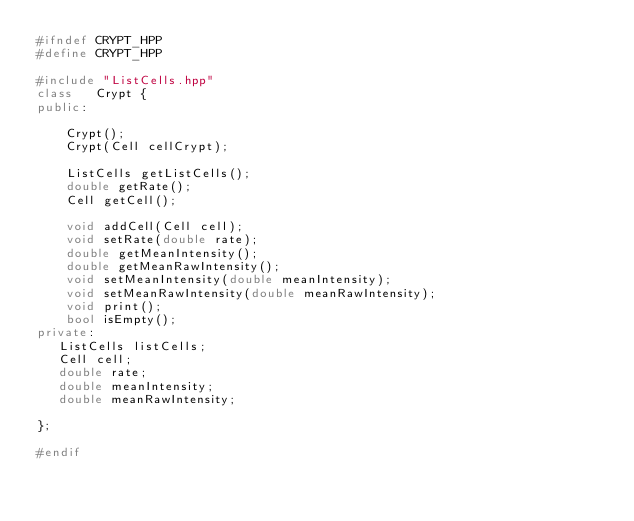<code> <loc_0><loc_0><loc_500><loc_500><_C++_>#ifndef CRYPT_HPP
#define CRYPT_HPP

#include "ListCells.hpp"
class	Crypt {
public:

	Crypt();
    Crypt(Cell cellCrypt);

	ListCells getListCells();
	double getRate();
	Cell getCell();

    void addCell(Cell cell);
    void setRate(double rate);
	double getMeanIntensity();
	double getMeanRawIntensity();
	void setMeanIntensity(double meanIntensity);
	void setMeanRawIntensity(double meanRawIntensity);
	void print();
	bool isEmpty();
private:
   ListCells listCells;
   Cell cell;
   double rate;
   double meanIntensity;
   double meanRawIntensity;

};

#endif
</code> 